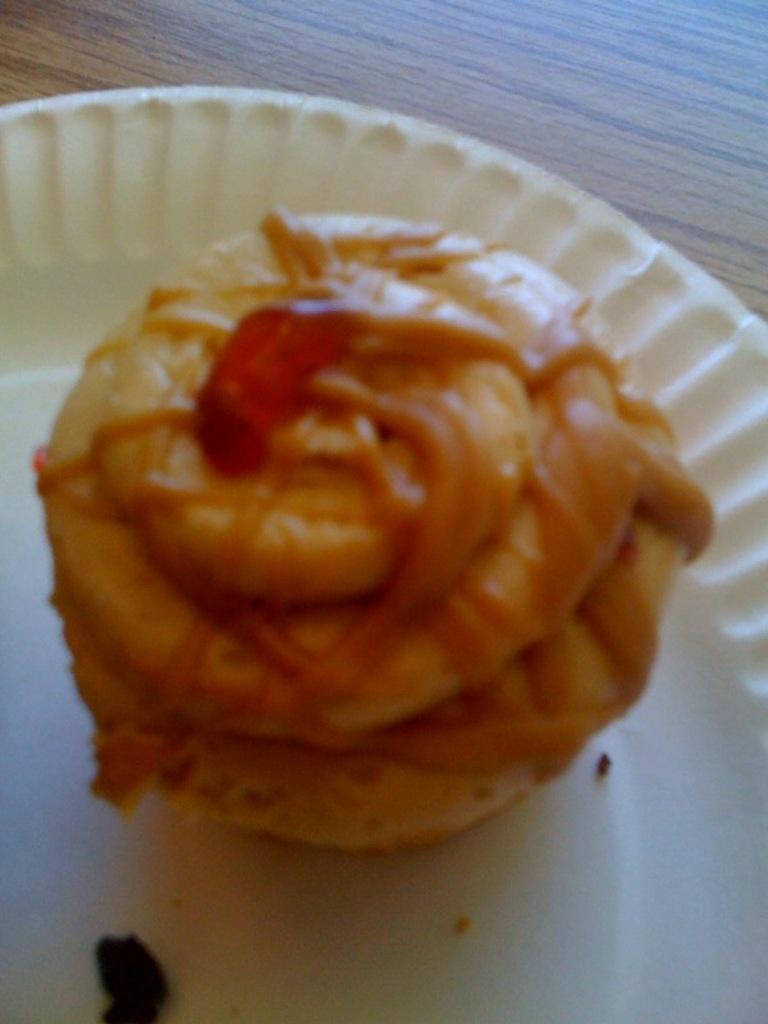Please provide a concise description of this image. In this image we can see a food item in a white color plate. At top of the image wooden surface is there. 